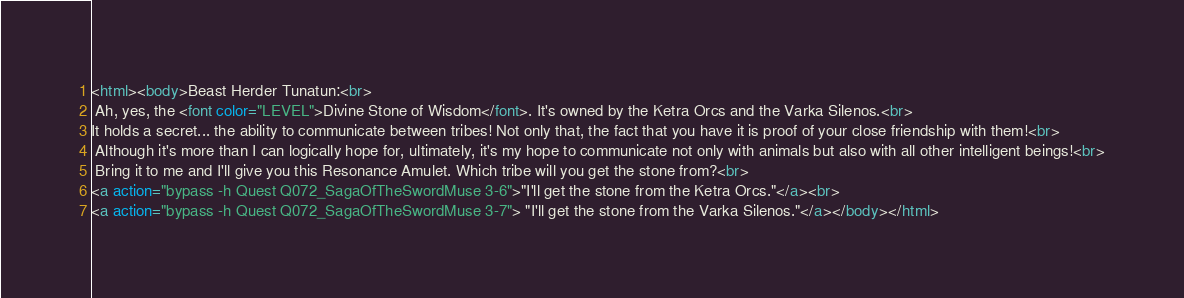Convert code to text. <code><loc_0><loc_0><loc_500><loc_500><_HTML_><html><body>Beast Herder Tunatun:<br>
 Ah, yes, the <font color="LEVEL">Divine Stone of Wisdom</font>. It's owned by the Ketra Orcs and the Varka Silenos.<br>
It holds a secret... the ability to communicate between tribes! Not only that, the fact that you have it is proof of your close friendship with them!<br>
 Although it's more than I can logically hope for, ultimately, it's my hope to communicate not only with animals but also with all other intelligent beings!<br>
 Bring it to me and I'll give you this Resonance Amulet. Which tribe will you get the stone from?<br>
<a action="bypass -h Quest Q072_SagaOfTheSwordMuse 3-6">"I'll get the stone from the Ketra Orcs."</a><br>
<a action="bypass -h Quest Q072_SagaOfTheSwordMuse 3-7"> "I'll get the stone from the Varka Silenos."</a></body></html></code> 